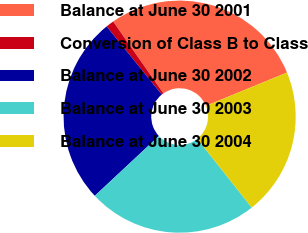Convert chart. <chart><loc_0><loc_0><loc_500><loc_500><pie_chart><fcel>Balance at June 30 2001<fcel>Conversion of Class B to Class<fcel>Balance at June 30 2002<fcel>Balance at June 30 2003<fcel>Balance at June 30 2004<nl><fcel>28.51%<fcel>1.12%<fcel>26.12%<fcel>23.72%<fcel>20.53%<nl></chart> 